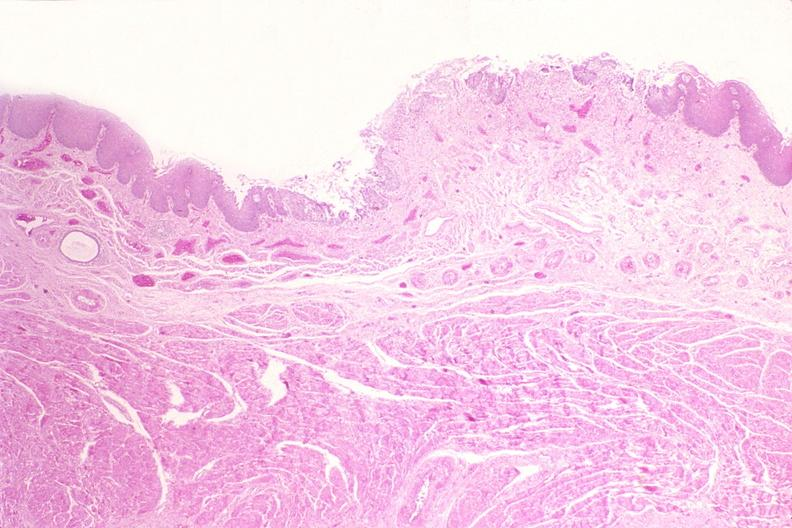what does this image show?
Answer the question using a single word or phrase. Esophagus 